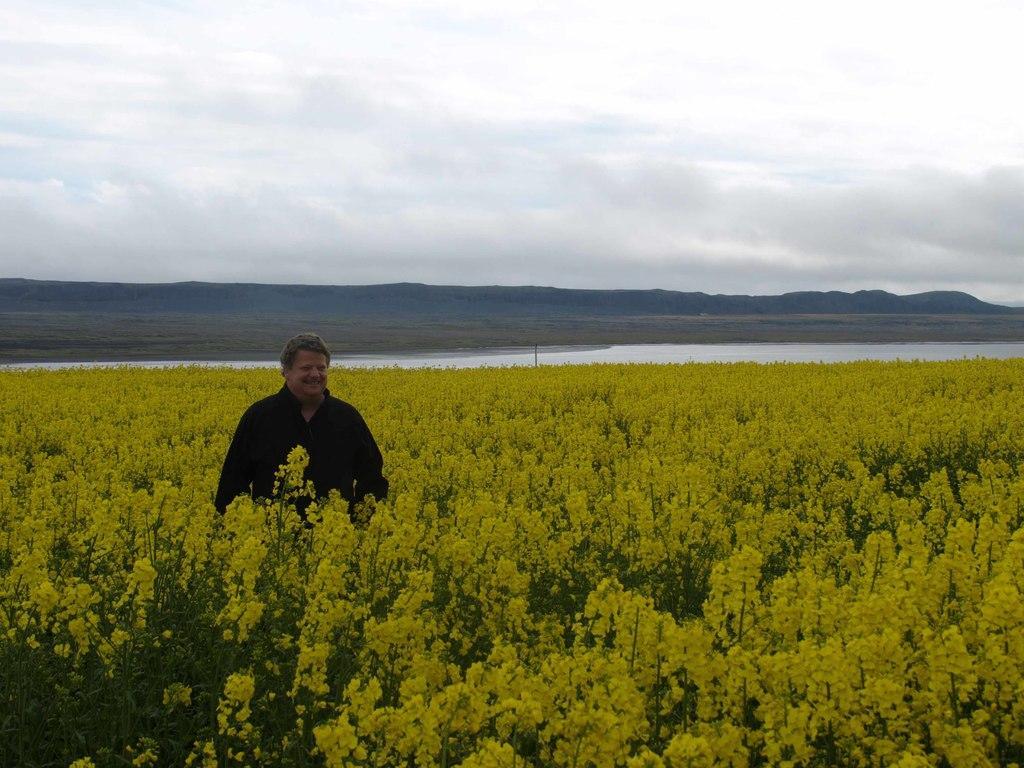Could you give a brief overview of what you see in this image? As we can see in the image there are plants, flowers, a man wearing black color shirt, water and at the top there is sky. 